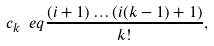<formula> <loc_0><loc_0><loc_500><loc_500>c _ { k } \ e q \frac { ( i + 1 ) \dots ( i ( k - 1 ) + 1 ) } { k ! } ,</formula> 